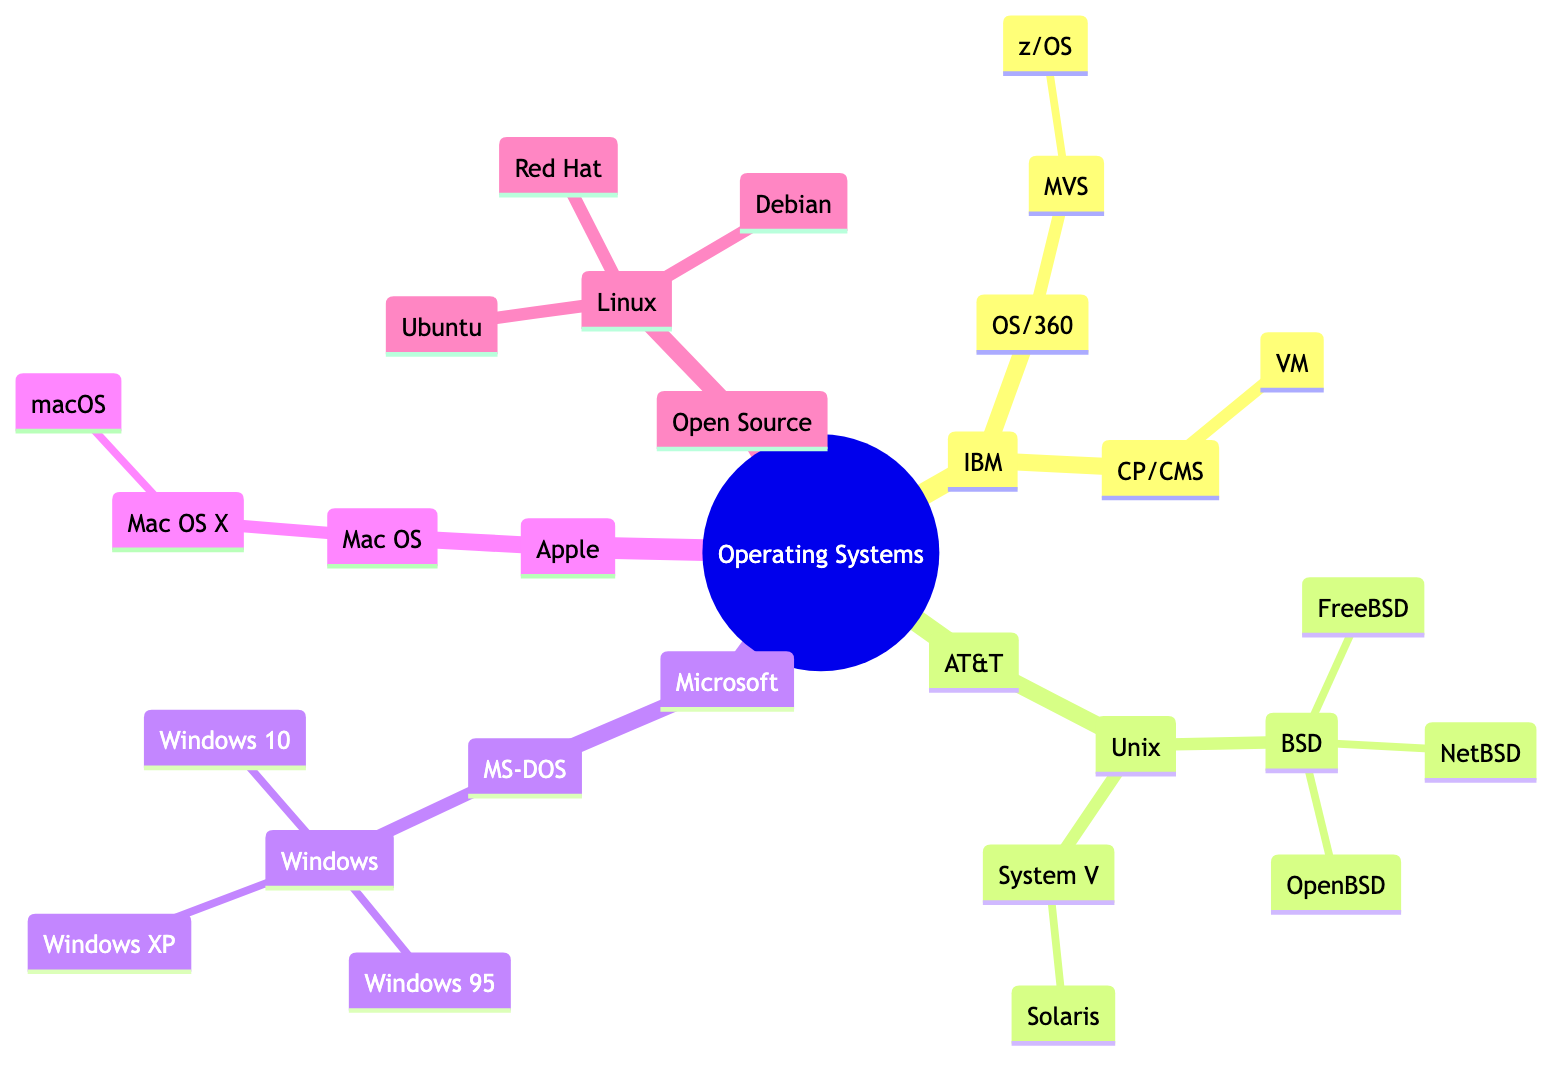What are the descendants of IBM? The descendants of IBM are OS/360, CP/CMS, which are children nodes directly under IBM. This can be observed by tracing the lines that connect the nodes beneath the IBM parent node.
Answer: OS/360, CP/CMS Which year did Unix originate? Unix originated in 1969, which is indicated by the year attached to the Unix node in the diagram.
Answer: 1969 How many direct descendants does Microsoft have? Microsoft has one direct descendant, which is MS-DOS, as there is a single line connecting Microsoft to MS-DOS.
Answer: 1 Name one operating system derived from BSD. FreeBSD is one of the descendants derived from BSD, as seen in the branching under the BSD node.
Answer: FreeBSD What is the relationship between OS/360 and MVS? OS/360 is the parent of MVS, demonstrated by the hierarchical structure where MVS is directly beneath OS/360 in the diagram.
Answer: Parent How many versions of Windows are listed? There are three versions of Windows listed: Windows 95, Windows XP, and Windows 10, as they are all children of the Windows node under Microsoft.
Answer: 3 Which operating system is associated with Apple? The operating system associated with Apple is Mac OS, as it is the first child node under the Apple parent.
Answer: Mac OS Which family tree has the most descendants? The AT&T family tree has the most descendants, as it includes multiple children under Unix, which further splits into several descendants under BSD and System V.
Answer: AT&T What type of operating system is Linux categorized as? Linux is categorized as an open-source Unix-like operating system, which is specified in the description under the Linux node.
Answer: Open-source Unix-like 